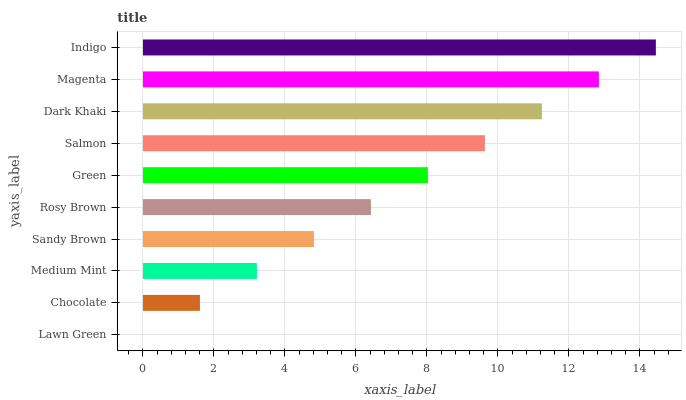Is Lawn Green the minimum?
Answer yes or no. Yes. Is Indigo the maximum?
Answer yes or no. Yes. Is Chocolate the minimum?
Answer yes or no. No. Is Chocolate the maximum?
Answer yes or no. No. Is Chocolate greater than Lawn Green?
Answer yes or no. Yes. Is Lawn Green less than Chocolate?
Answer yes or no. Yes. Is Lawn Green greater than Chocolate?
Answer yes or no. No. Is Chocolate less than Lawn Green?
Answer yes or no. No. Is Green the high median?
Answer yes or no. Yes. Is Rosy Brown the low median?
Answer yes or no. Yes. Is Magenta the high median?
Answer yes or no. No. Is Chocolate the low median?
Answer yes or no. No. 